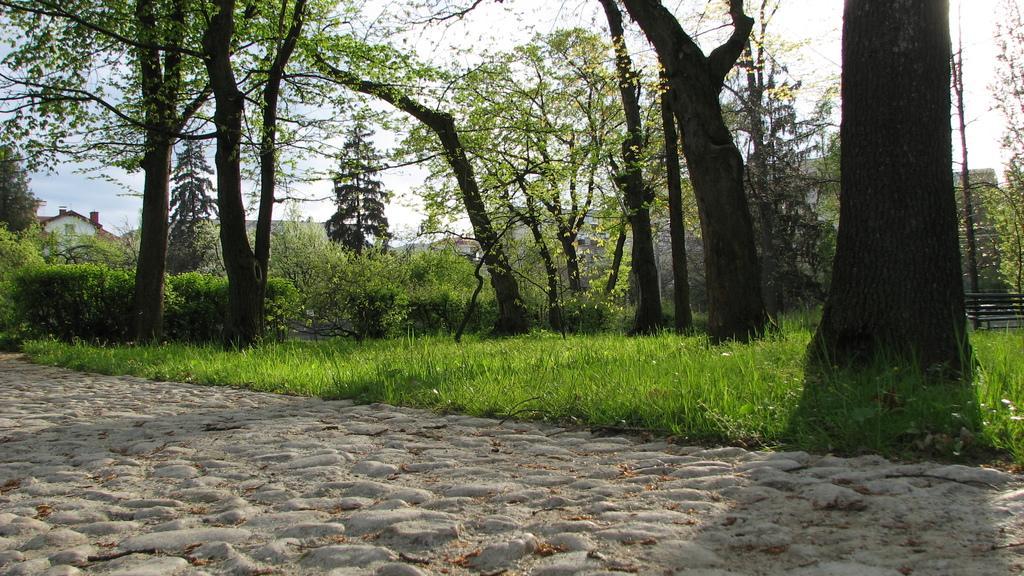How would you summarize this image in a sentence or two? In this image we can see grassy land, trees and buildings. At the bottom of the image, we can see the dry leaves on the land. At the top of the image, we can see the sky. There is a bench on the right side of the image. 